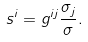<formula> <loc_0><loc_0><loc_500><loc_500>s ^ { i } = g ^ { i j } \frac { \sigma _ { j } } { \sigma } .</formula> 